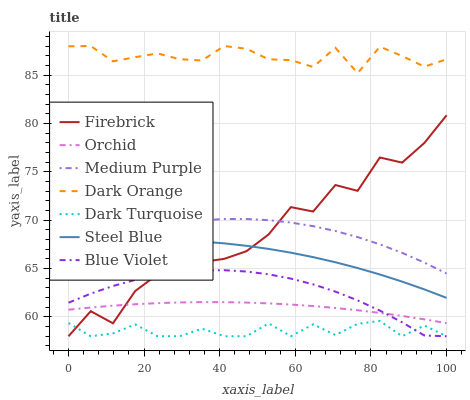Does Dark Turquoise have the minimum area under the curve?
Answer yes or no. Yes. Does Dark Orange have the maximum area under the curve?
Answer yes or no. Yes. Does Firebrick have the minimum area under the curve?
Answer yes or no. No. Does Firebrick have the maximum area under the curve?
Answer yes or no. No. Is Orchid the smoothest?
Answer yes or no. Yes. Is Firebrick the roughest?
Answer yes or no. Yes. Is Dark Turquoise the smoothest?
Answer yes or no. No. Is Dark Turquoise the roughest?
Answer yes or no. No. Does Dark Turquoise have the lowest value?
Answer yes or no. Yes. Does Steel Blue have the lowest value?
Answer yes or no. No. Does Dark Orange have the highest value?
Answer yes or no. Yes. Does Firebrick have the highest value?
Answer yes or no. No. Is Dark Turquoise less than Orchid?
Answer yes or no. Yes. Is Dark Orange greater than Orchid?
Answer yes or no. Yes. Does Dark Turquoise intersect Blue Violet?
Answer yes or no. Yes. Is Dark Turquoise less than Blue Violet?
Answer yes or no. No. Is Dark Turquoise greater than Blue Violet?
Answer yes or no. No. Does Dark Turquoise intersect Orchid?
Answer yes or no. No. 